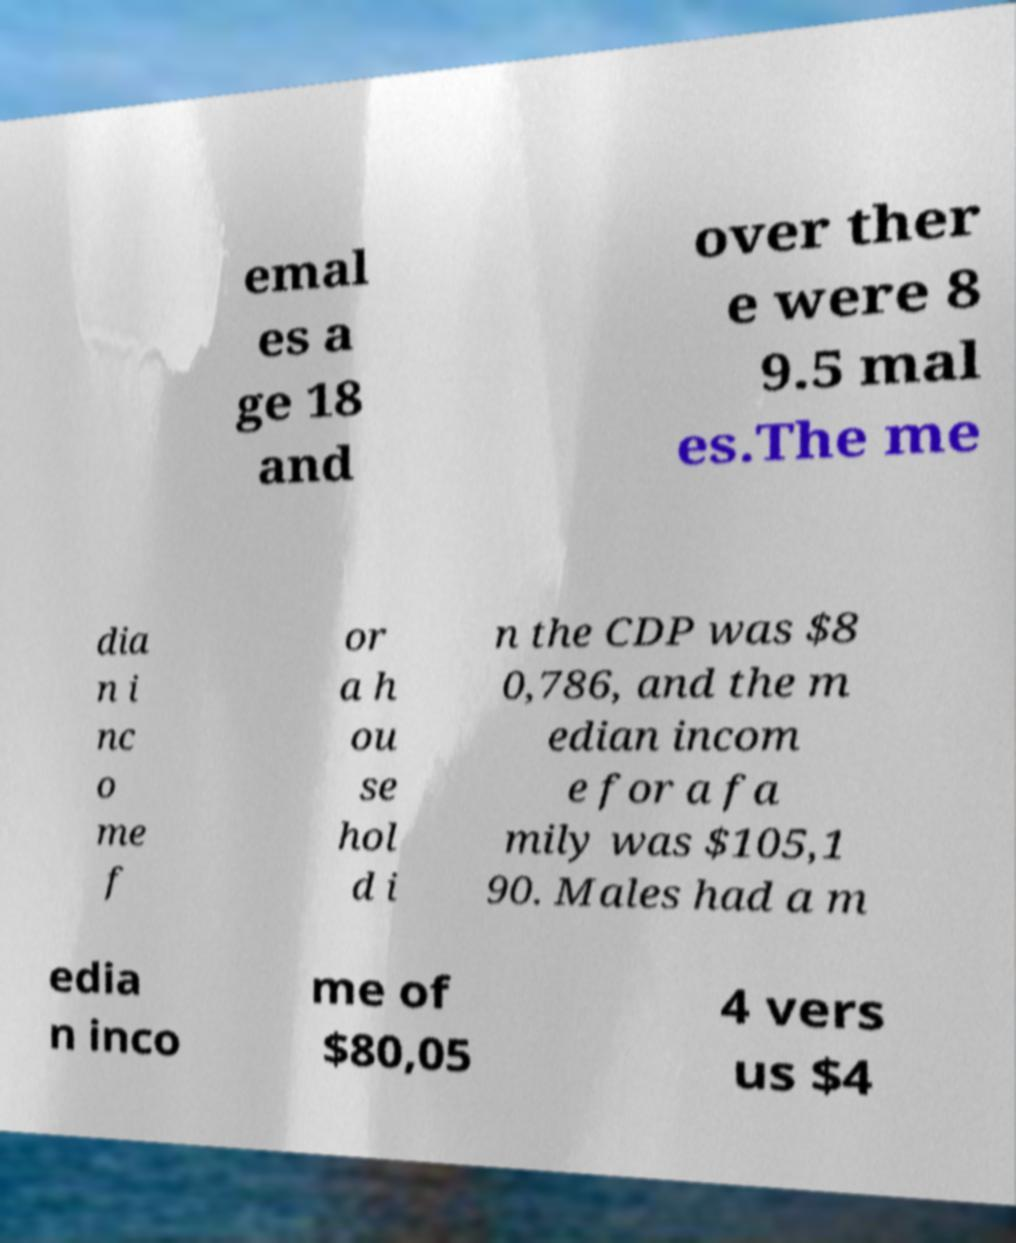Can you read and provide the text displayed in the image?This photo seems to have some interesting text. Can you extract and type it out for me? emal es a ge 18 and over ther e were 8 9.5 mal es.The me dia n i nc o me f or a h ou se hol d i n the CDP was $8 0,786, and the m edian incom e for a fa mily was $105,1 90. Males had a m edia n inco me of $80,05 4 vers us $4 